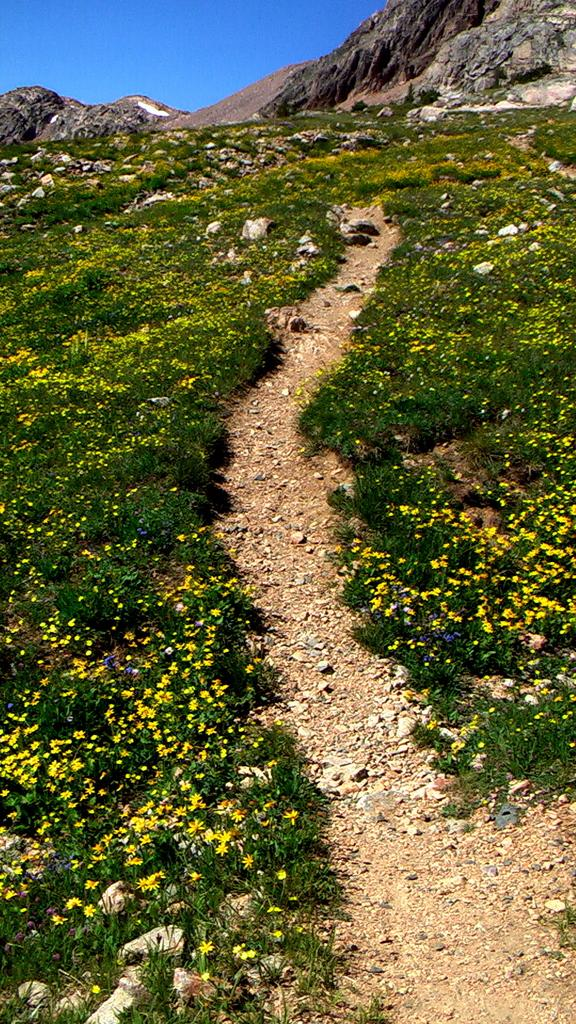What is the main subject in the foreground of the image? There is a path on a mountain in the foreground of the image. What type of vegetation can be seen alongside the path? Plants with flowers are present on either side of the path. What can be seen in the background of the image? There are cliffs visible in the background of the image, as well as the sky. What type of guide can be seen leading a group of tourists downtown in the image? There is no guide or tourists present in the image; it features a path on a mountain with plants and cliffs in the background. 